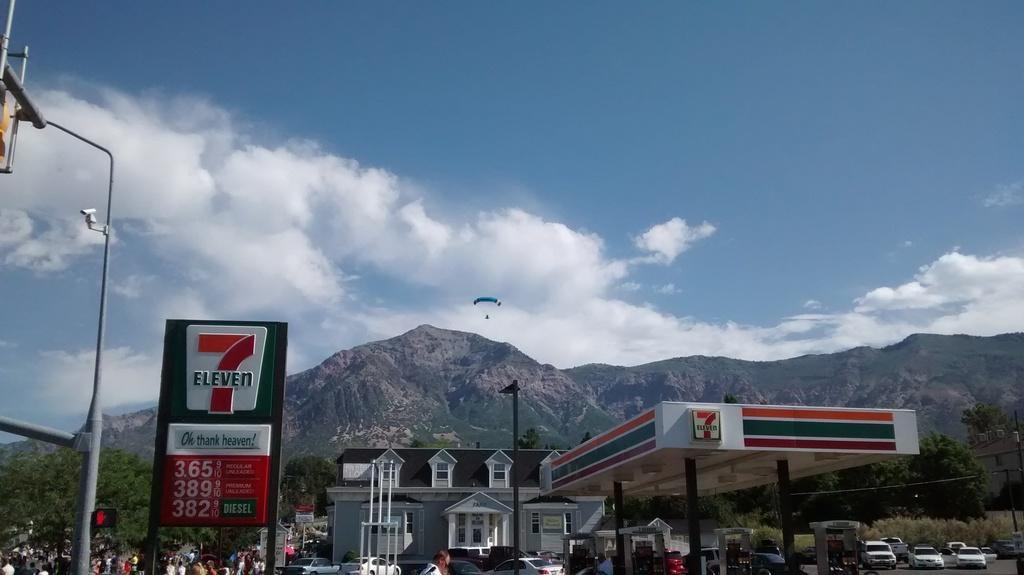Could you give a brief overview of what you see in this image? There are vehicles, people, a house, poles and a roof in the foreground area of the image, there are mountains, a parachute and the sky in the background. 